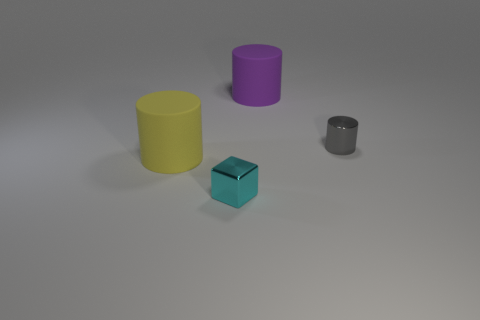How many balls are tiny cyan metallic things or small gray metal things?
Provide a short and direct response. 0. There is a metal thing on the right side of the purple matte cylinder; is its shape the same as the cyan thing?
Your response must be concise. No. Is the number of tiny blocks that are on the left side of the tiny cyan object greater than the number of tiny shiny blocks?
Your answer should be very brief. No. There is a object that is the same size as the cube; what is its color?
Ensure brevity in your answer.  Gray. How many objects are either cylinders that are left of the tiny gray thing or large yellow cylinders?
Offer a very short reply. 2. What material is the cylinder on the left side of the big matte thing on the right side of the block made of?
Ensure brevity in your answer.  Rubber. Is there a large purple cylinder that has the same material as the tiny cyan thing?
Your answer should be compact. No. Are there any large cylinders that are on the left side of the large cylinder right of the cyan thing?
Offer a terse response. Yes. There is a large thing that is in front of the big purple rubber cylinder; what is its material?
Your answer should be very brief. Rubber. Is the shape of the tiny gray metallic thing the same as the small cyan thing?
Your answer should be very brief. No. 